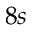Convert formula to latex. <formula><loc_0><loc_0><loc_500><loc_500>8 s</formula> 